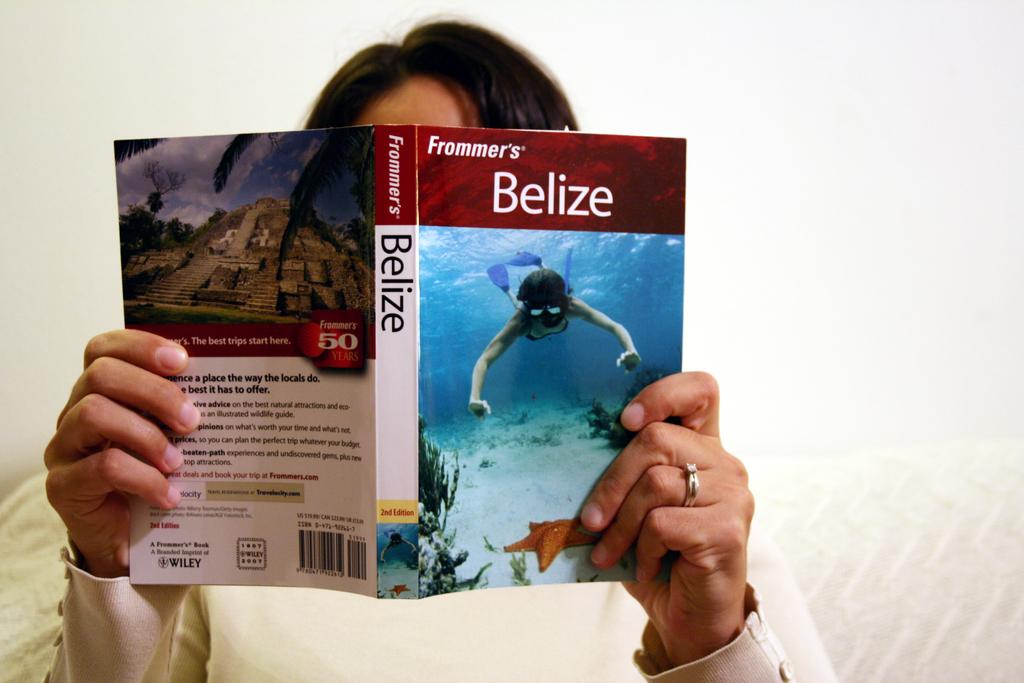<image>
Relay a brief, clear account of the picture shown. A person is holding a book about Belize. 